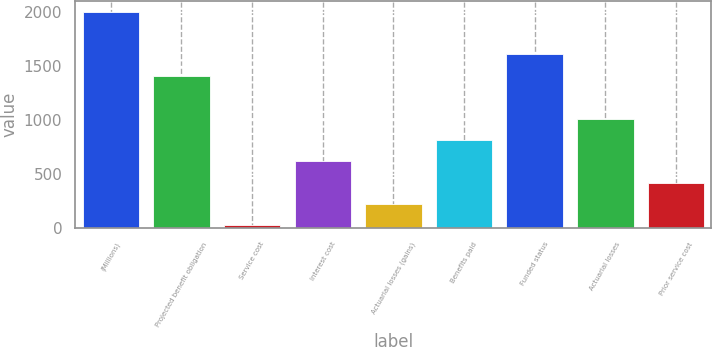<chart> <loc_0><loc_0><loc_500><loc_500><bar_chart><fcel>(Millions)<fcel>Projected benefit obligation<fcel>Service cost<fcel>Interest cost<fcel>Actuarial losses (gains)<fcel>Benefits paid<fcel>Funded status<fcel>Actuarial losses<fcel>Prior service cost<nl><fcel>2005<fcel>1410.7<fcel>24<fcel>618.3<fcel>222.1<fcel>816.4<fcel>1608.8<fcel>1014.5<fcel>420.2<nl></chart> 